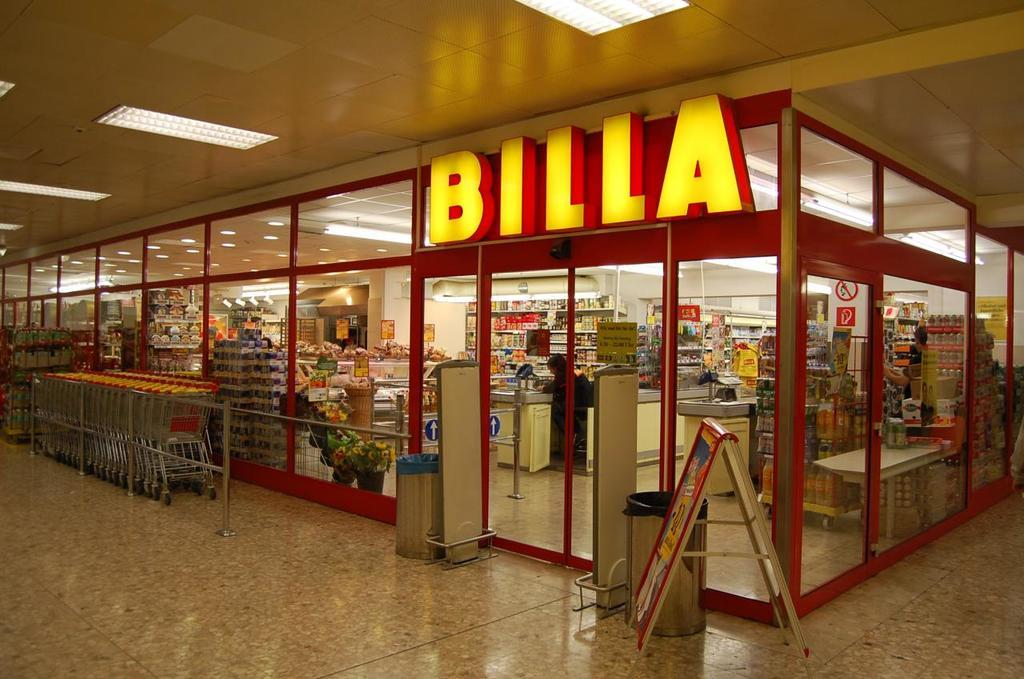<image>
Present a compact description of the photo's key features. A store called Billa with only one person visible. 